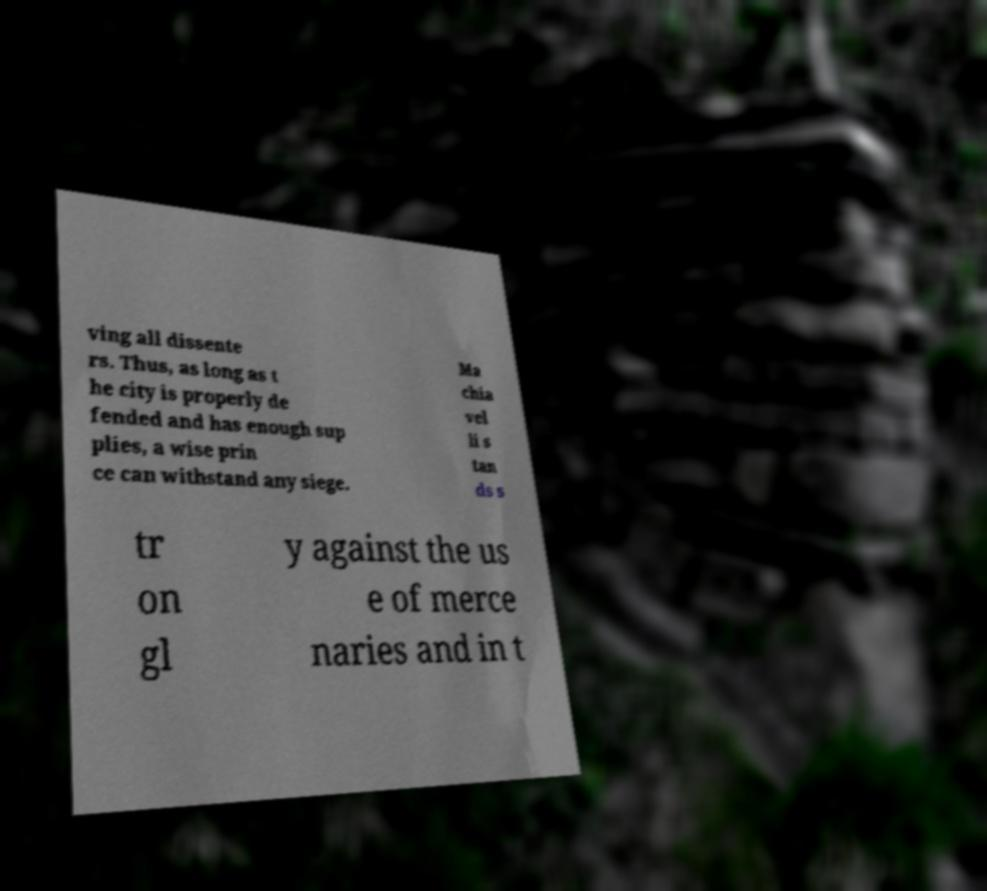There's text embedded in this image that I need extracted. Can you transcribe it verbatim? ving all dissente rs. Thus, as long as t he city is properly de fended and has enough sup plies, a wise prin ce can withstand any siege. Ma chia vel li s tan ds s tr on gl y against the us e of merce naries and in t 